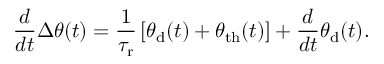<formula> <loc_0><loc_0><loc_500><loc_500>\frac { d } { d t } \Delta \theta ( t ) = \frac { 1 } { \tau _ { r } } \left [ \theta _ { d } ( t ) + \theta _ { t h } ( t ) \right ] + \frac { d } { d t } \theta _ { d } ( t ) .</formula> 